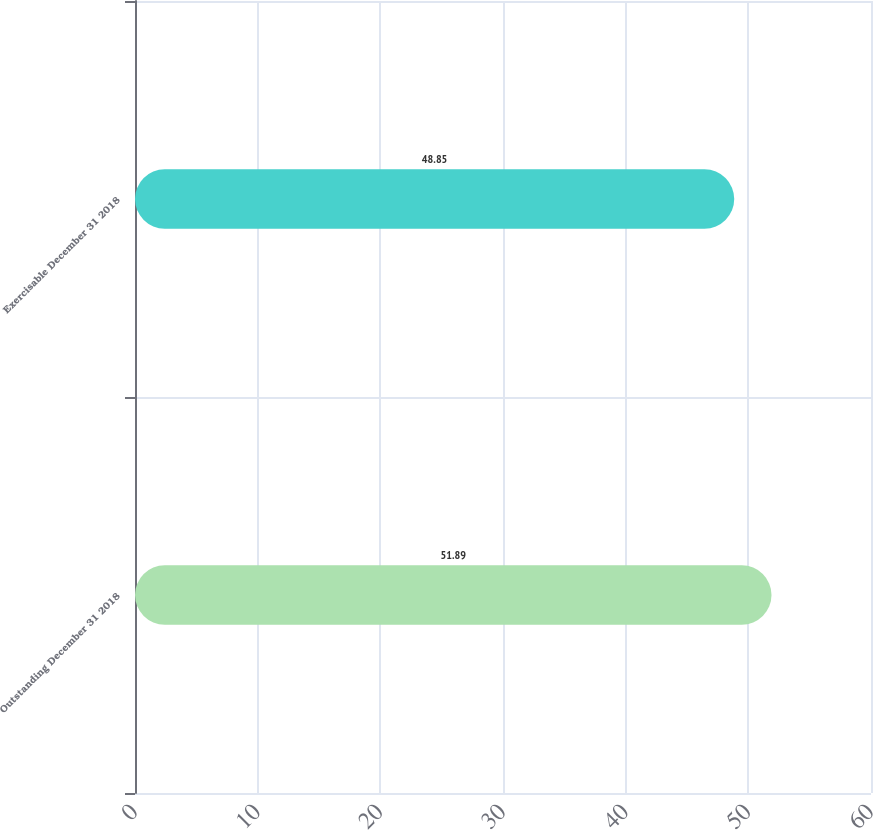Convert chart. <chart><loc_0><loc_0><loc_500><loc_500><bar_chart><fcel>Outstanding December 31 2018<fcel>Exercisable December 31 2018<nl><fcel>51.89<fcel>48.85<nl></chart> 